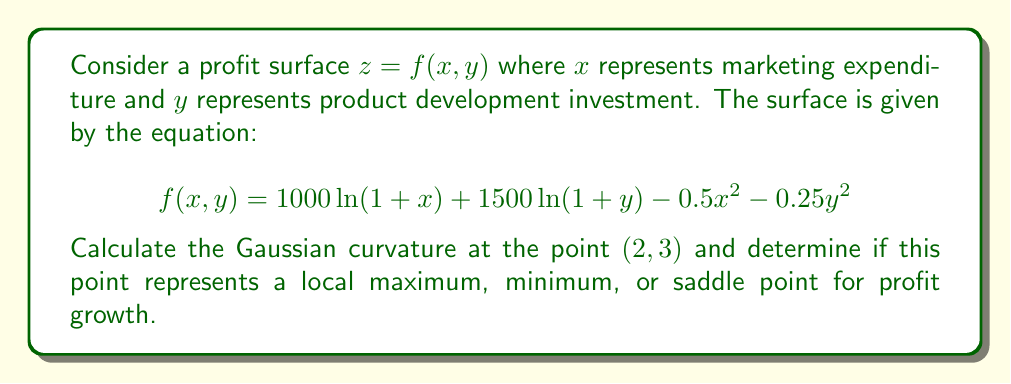Solve this math problem. To analyze the Gaussian curvature and determine the nature of the point (2, 3), we'll follow these steps:

1) First, we need to calculate the partial derivatives up to the second order:

   $f_x = \frac{1000}{1+x} - x$
   $f_y = \frac{1500}{1+y} - 0.5y$
   
   $f_{xx} = -\frac{1000}{(1+x)^2} - 1$
   $f_{yy} = -\frac{1500}{(1+y)^2} - 0.5$
   $f_{xy} = f_{yx} = 0$

2) The Gaussian curvature K is given by:

   $$K = \frac{f_{xx}f_{yy} - f_{xy}^2}{(1 + f_x^2 + f_y^2)^2}$$

3) Let's evaluate the derivatives at (2, 3):

   $f_x(2, 3) = \frac{1000}{3} - 2 = 331.33$
   $f_y(2, 3) = \frac{1500}{4} - 1.5 = 373.5$
   
   $f_{xx}(2, 3) = -\frac{1000}{9} - 1 = -112.11$
   $f_{yy}(2, 3) = -\frac{1500}{16} - 0.5 = -94.25$
   $f_{xy}(2, 3) = 0$

4) Now we can calculate K:

   $$K = \frac{(-112.11)(-94.25) - 0^2}{(1 + 331.33^2 + 373.5^2)^2}$$
   
   $$K = \frac{10566.37}{(247,530.62)^2} \approx 1.724 \times 10^{-7}$$

5) Since K > 0, the point (2, 3) is either a local maximum or minimum.

6) To determine which, we need to check the sign of $f_{xx}$ or $f_{yy}$:
   Both $f_{xx}$ and $f_{yy}$ are negative, indicating that (2, 3) is a local maximum.
Answer: K ≈ 1.724 × 10^-7; local maximum 